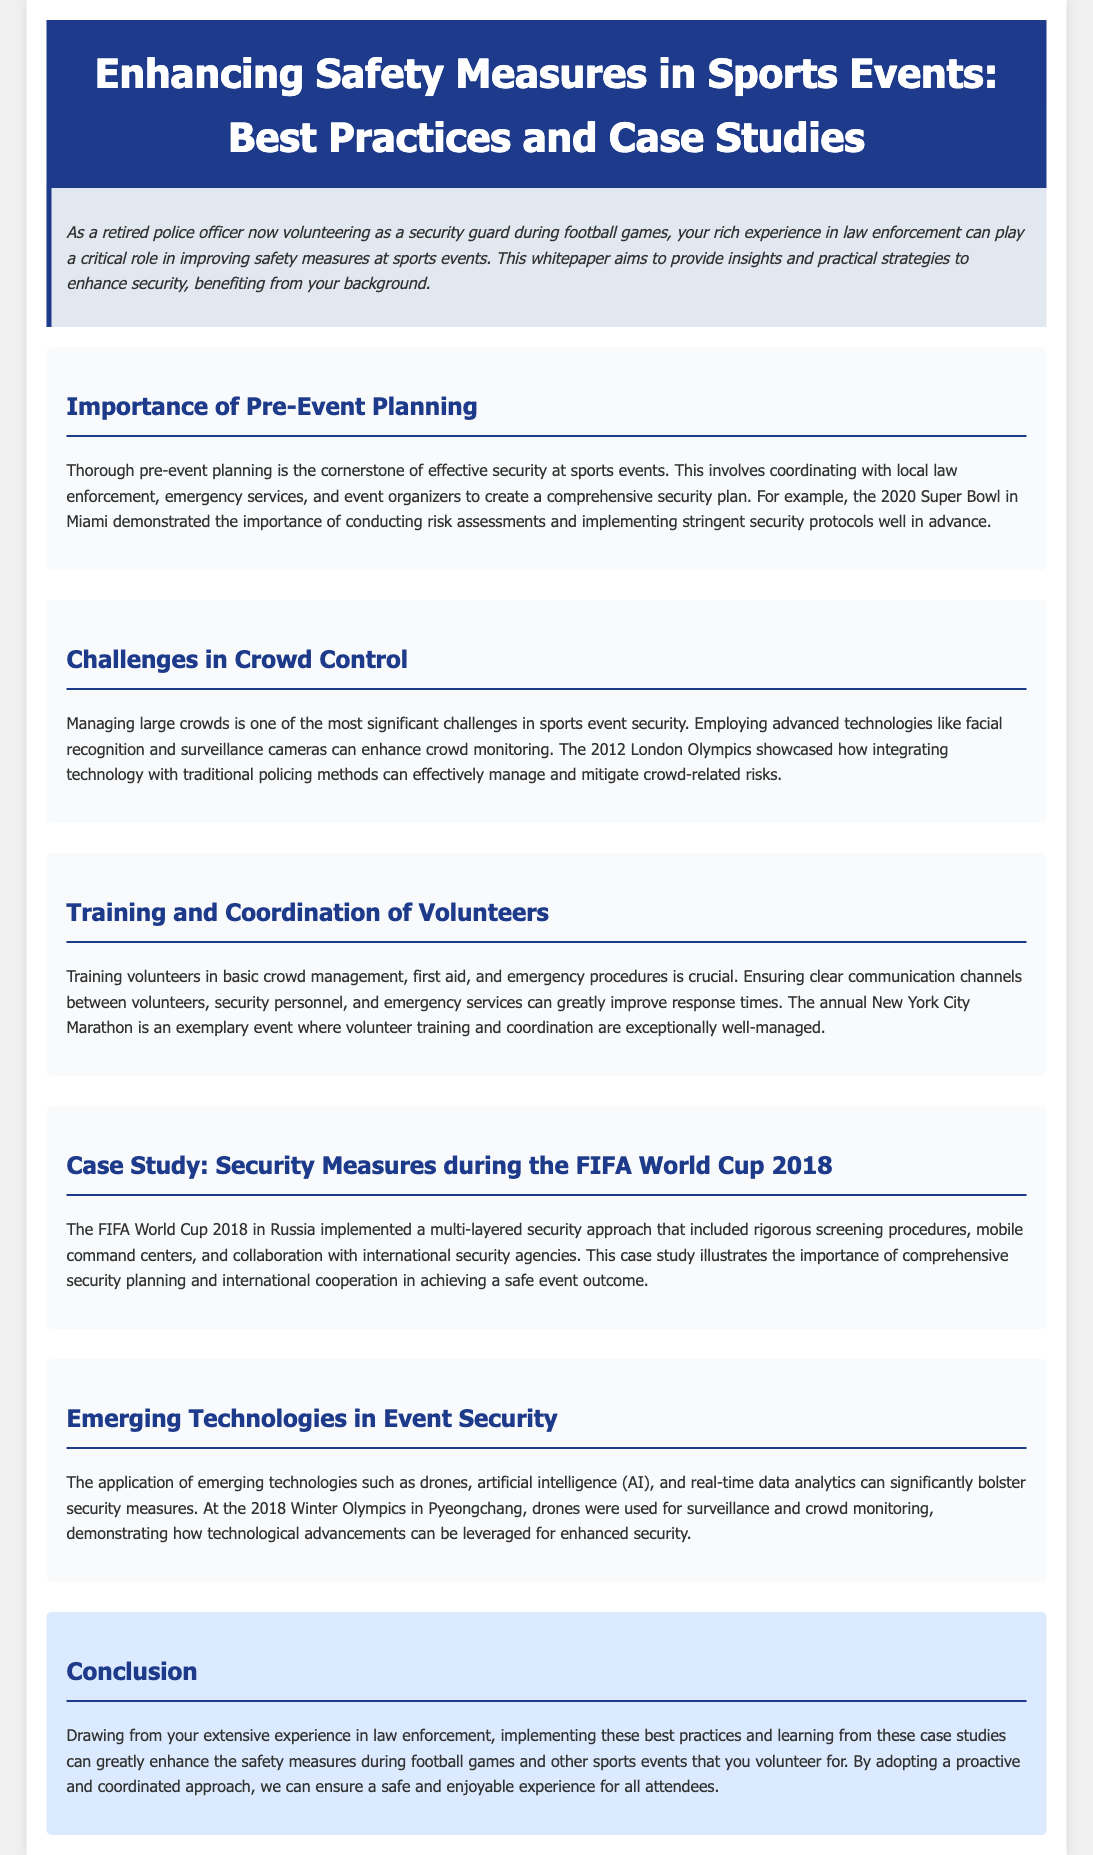What is the title of the whitepaper? The title of the whitepaper is indicated at the top of the document.
Answer: Enhancing Safety Measures in Sports Events: Best Practices and Case Studies What event showcased the importance of pre-event planning? The document mentions an example of an event that highlighted the need for pre-event security planning.
Answer: 2020 Super Bowl What advanced technology is mentioned for crowd control? The whitepaper lists technologies that aid in monitoring crowds during events.
Answer: Facial recognition Which marathon is noted for exceptional volunteer training? The document refers to an event known for its organization and volunteer management.
Answer: New York City Marathon How many layers of security were implemented during the FIFA World Cup 2018? The text describes a security approach characterized by a specific number of layers.
Answer: Multi-layered What emerging technology was used for surveillance during the 2018 Winter Olympics? The whitepaper provides an example of a technology utilized for security during this event.
Answer: Drones Who should be coordinated with during pre-event planning? The document emphasizes the need to collaborate with specific groups during pre-event security measures.
Answer: Local law enforcement, emergency services, event organizers What year did the FIFA World Cup take place that is discussed in the case study? The text specifies the year of the mentioned FIFA World Cup in the case study.
Answer: 2018 What theme is highlighted in the conclusion of the whitepaper? The document's conclusion summarizes the key theme addressed throughout the text.
Answer: Proactive and coordinated approach 